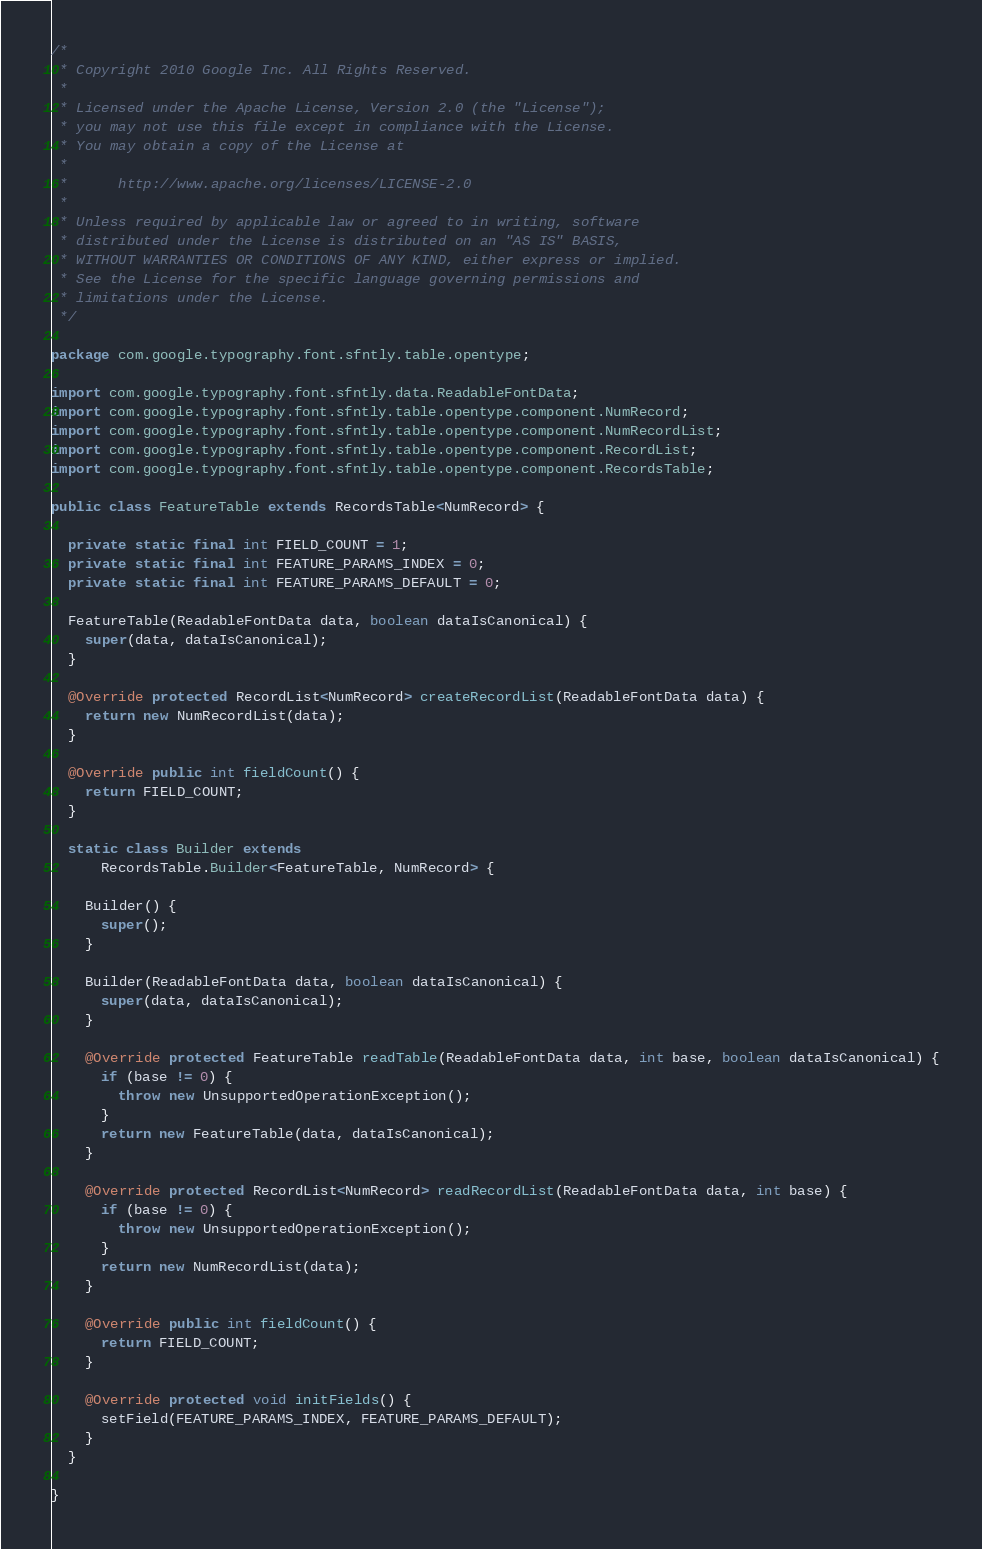<code> <loc_0><loc_0><loc_500><loc_500><_Java_>/*
 * Copyright 2010 Google Inc. All Rights Reserved.
 *
 * Licensed under the Apache License, Version 2.0 (the "License");
 * you may not use this file except in compliance with the License.
 * You may obtain a copy of the License at
 *
 *      http://www.apache.org/licenses/LICENSE-2.0
 *
 * Unless required by applicable law or agreed to in writing, software
 * distributed under the License is distributed on an "AS IS" BASIS,
 * WITHOUT WARRANTIES OR CONDITIONS OF ANY KIND, either express or implied.
 * See the License for the specific language governing permissions and
 * limitations under the License.
 */

package com.google.typography.font.sfntly.table.opentype;

import com.google.typography.font.sfntly.data.ReadableFontData;
import com.google.typography.font.sfntly.table.opentype.component.NumRecord;
import com.google.typography.font.sfntly.table.opentype.component.NumRecordList;
import com.google.typography.font.sfntly.table.opentype.component.RecordList;
import com.google.typography.font.sfntly.table.opentype.component.RecordsTable;

public class FeatureTable extends RecordsTable<NumRecord> {

  private static final int FIELD_COUNT = 1;
  private static final int FEATURE_PARAMS_INDEX = 0;
  private static final int FEATURE_PARAMS_DEFAULT = 0;

  FeatureTable(ReadableFontData data, boolean dataIsCanonical) {
    super(data, dataIsCanonical);
  }

  @Override protected RecordList<NumRecord> createRecordList(ReadableFontData data) {
    return new NumRecordList(data);
  }

  @Override public int fieldCount() {
    return FIELD_COUNT;
  }

  static class Builder extends
      RecordsTable.Builder<FeatureTable, NumRecord> {

    Builder() {
      super();
    }

    Builder(ReadableFontData data, boolean dataIsCanonical) {
      super(data, dataIsCanonical);
    }

    @Override protected FeatureTable readTable(ReadableFontData data, int base, boolean dataIsCanonical) {
      if (base != 0) {
        throw new UnsupportedOperationException();
      }
      return new FeatureTable(data, dataIsCanonical);
    }

    @Override protected RecordList<NumRecord> readRecordList(ReadableFontData data, int base) {
      if (base != 0) {
        throw new UnsupportedOperationException();
      }
      return new NumRecordList(data);
    }

    @Override public int fieldCount() {
      return FIELD_COUNT;
    }

    @Override protected void initFields() {
      setField(FEATURE_PARAMS_INDEX, FEATURE_PARAMS_DEFAULT);
    }
  }

}

</code> 